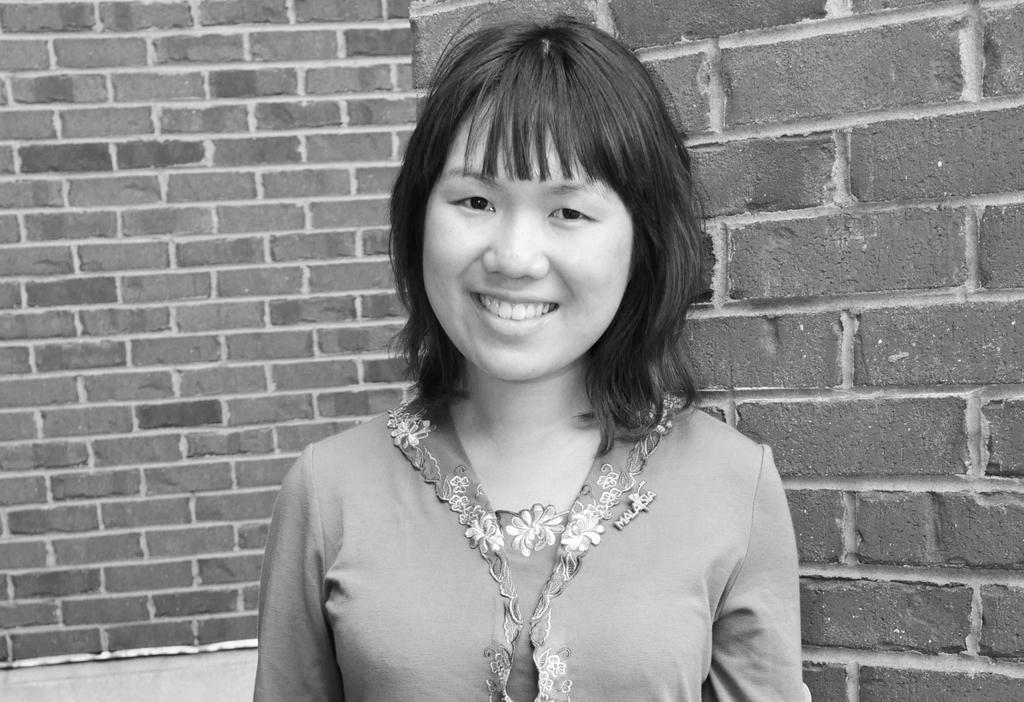What is the color scheme of the image? The image is black and white. Who is present in the image? There is a woman in the image. What is the woman's expression? The woman is smiling. What can be seen in the background of the image? There is a wall in the background of the image. What is the woman's digestive system like in the image? There is no information about the woman's digestive system in the image, as it is not visible or relevant to the image's content. 